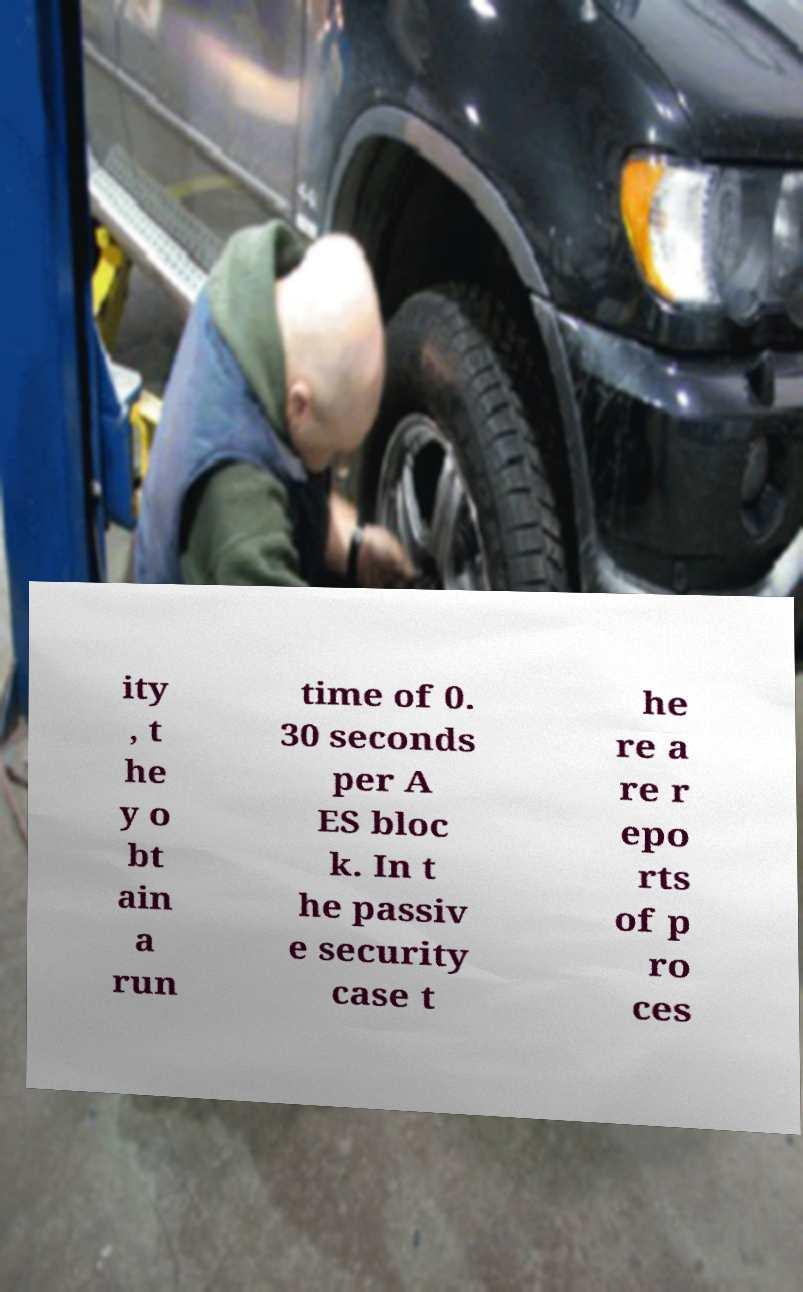Can you read and provide the text displayed in the image?This photo seems to have some interesting text. Can you extract and type it out for me? ity , t he y o bt ain a run time of 0. 30 seconds per A ES bloc k. In t he passiv e security case t he re a re r epo rts of p ro ces 